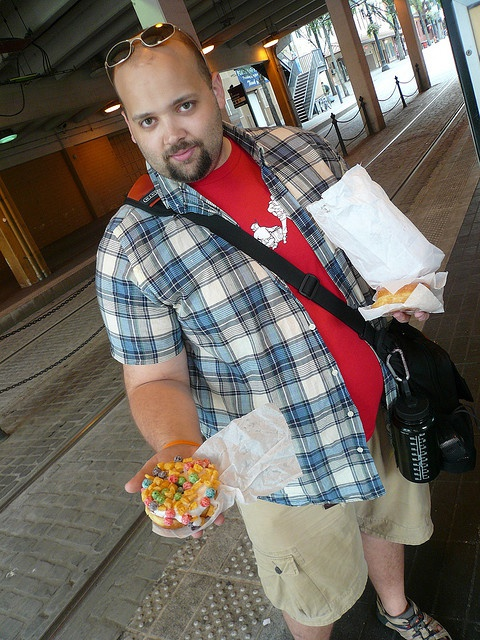Describe the objects in this image and their specific colors. I can see people in black, darkgray, lightgray, and gray tones, handbag in black, brown, gray, and darkgray tones, donut in black, red, orange, tan, and lightpink tones, sandwich in black and tan tones, and people in black, lightblue, darkgray, and gray tones in this image. 